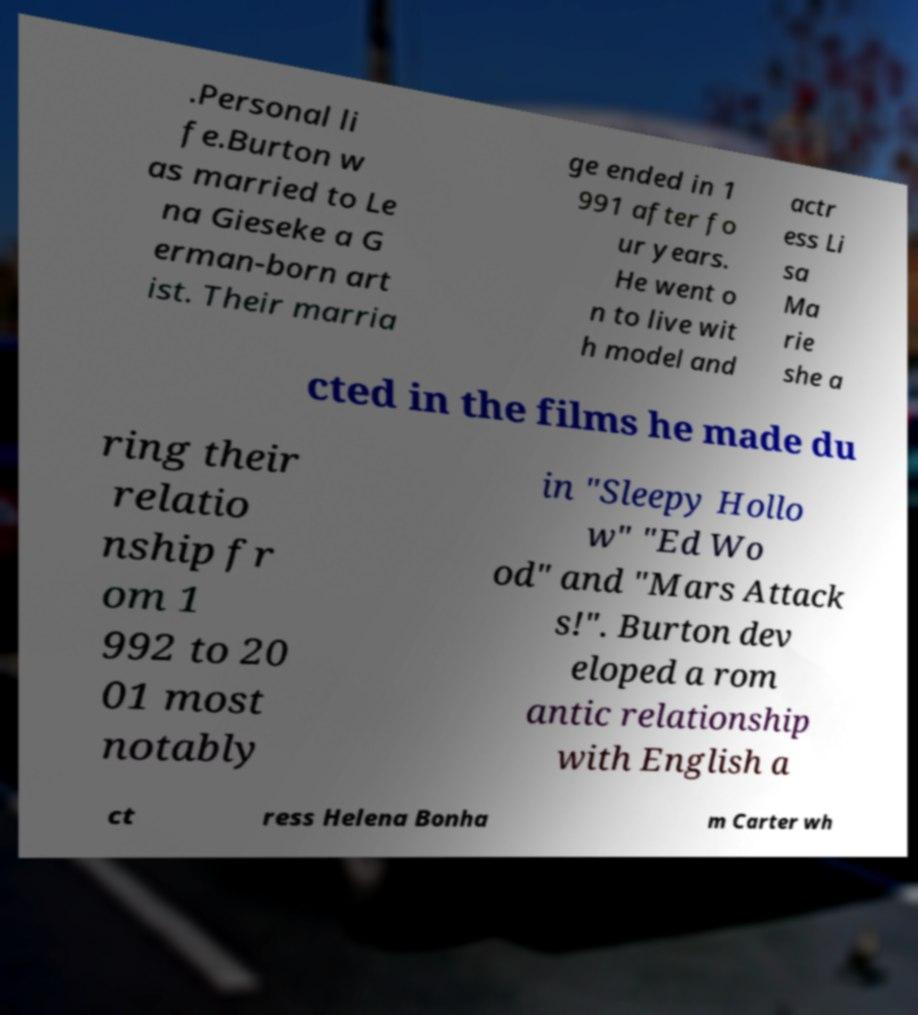What messages or text are displayed in this image? I need them in a readable, typed format. .Personal li fe.Burton w as married to Le na Gieseke a G erman-born art ist. Their marria ge ended in 1 991 after fo ur years. He went o n to live wit h model and actr ess Li sa Ma rie she a cted in the films he made du ring their relatio nship fr om 1 992 to 20 01 most notably in "Sleepy Hollo w" "Ed Wo od" and "Mars Attack s!". Burton dev eloped a rom antic relationship with English a ct ress Helena Bonha m Carter wh 